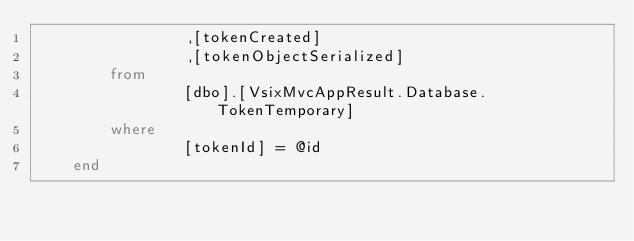<code> <loc_0><loc_0><loc_500><loc_500><_SQL_>				,[tokenCreated]
				,[tokenObjectSerialized]
		from  
				[dbo].[VsixMvcAppResult.Database.TokenTemporary]
		where
				[tokenId] = @id
	end</code> 